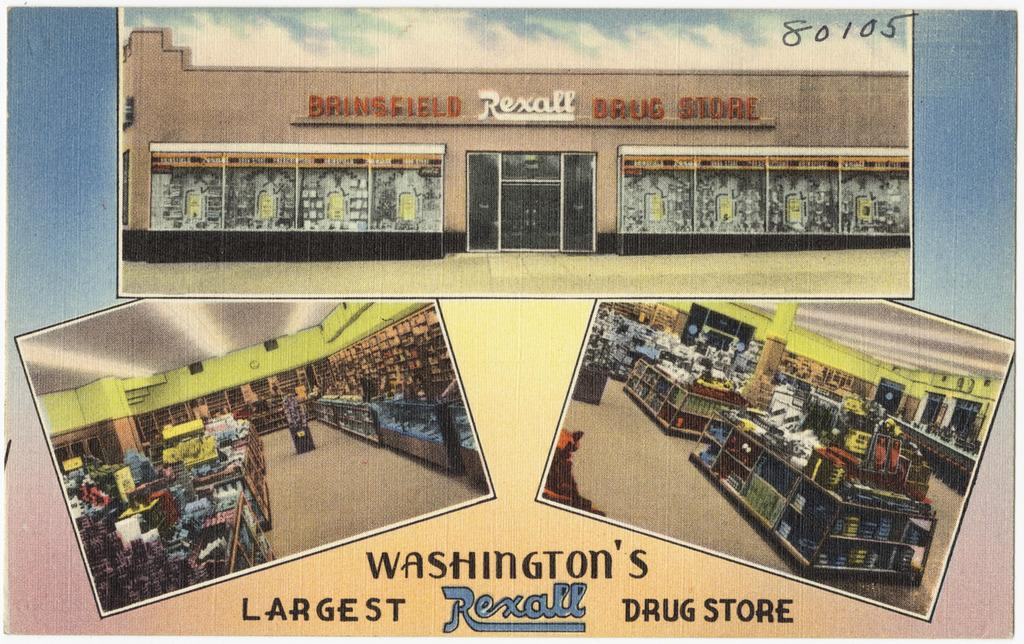<image>
Offer a succinct explanation of the picture presented. some pictures of the largest drugstore in Washington. 